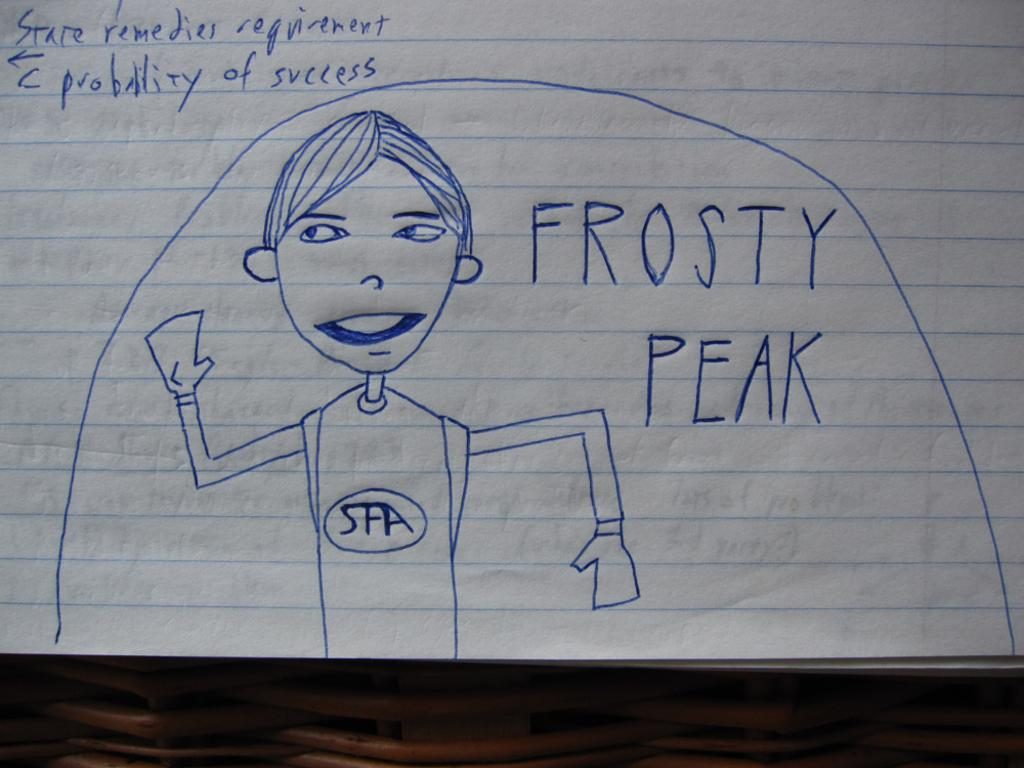What is present on the paper in the image? The paper contains text and a drawing of a boy. Can you describe the content of the text on the paper? Unfortunately, the specific content of the text cannot be determined from the image. What is the subject of the drawing on the paper? The drawing on the paper is of a boy. What type of milk is being poured into the drawing of the boy? There is no milk present in the image, as it features a paper with text and a drawing of a boy. How is the wound on the boy's arm being treated in the image? There is no wound present on the boy's arm in the image, as it only features a drawing of a boy. 